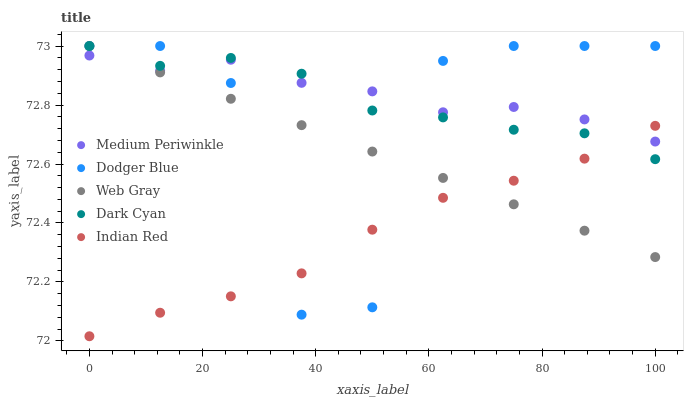Does Indian Red have the minimum area under the curve?
Answer yes or no. Yes. Does Medium Periwinkle have the maximum area under the curve?
Answer yes or no. Yes. Does Dodger Blue have the minimum area under the curve?
Answer yes or no. No. Does Dodger Blue have the maximum area under the curve?
Answer yes or no. No. Is Web Gray the smoothest?
Answer yes or no. Yes. Is Dodger Blue the roughest?
Answer yes or no. Yes. Is Dodger Blue the smoothest?
Answer yes or no. No. Is Web Gray the roughest?
Answer yes or no. No. Does Indian Red have the lowest value?
Answer yes or no. Yes. Does Dodger Blue have the lowest value?
Answer yes or no. No. Does Web Gray have the highest value?
Answer yes or no. Yes. Does Medium Periwinkle have the highest value?
Answer yes or no. No. Does Web Gray intersect Medium Periwinkle?
Answer yes or no. Yes. Is Web Gray less than Medium Periwinkle?
Answer yes or no. No. Is Web Gray greater than Medium Periwinkle?
Answer yes or no. No. 